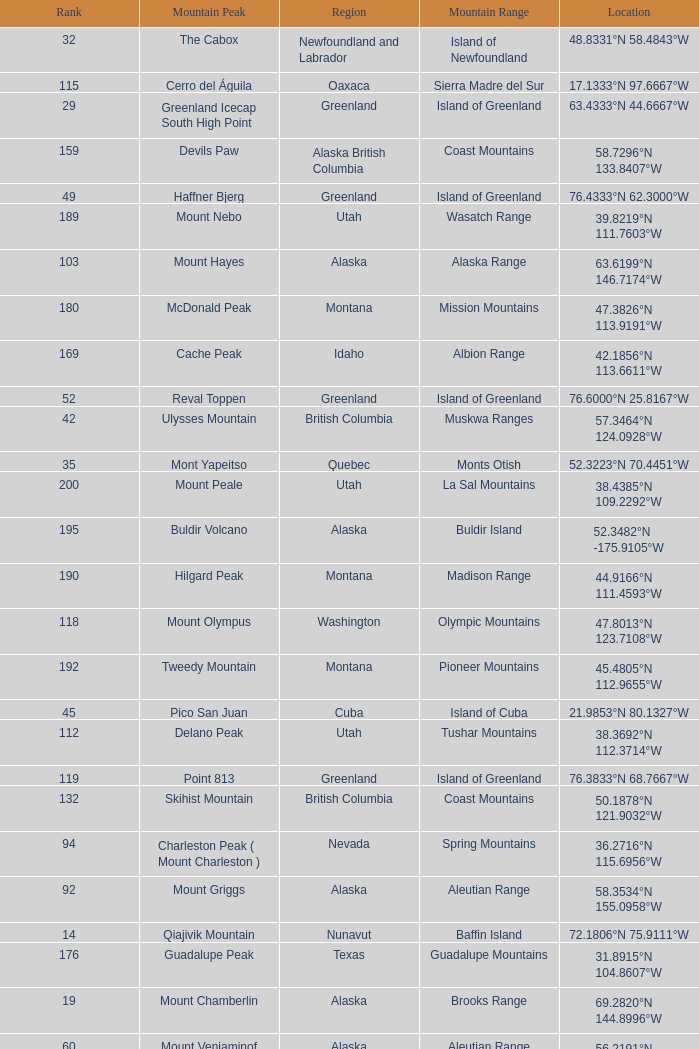Name the Mountain Peak which has a Rank of 62? Cerro Nube ( Quie Yelaag ). 